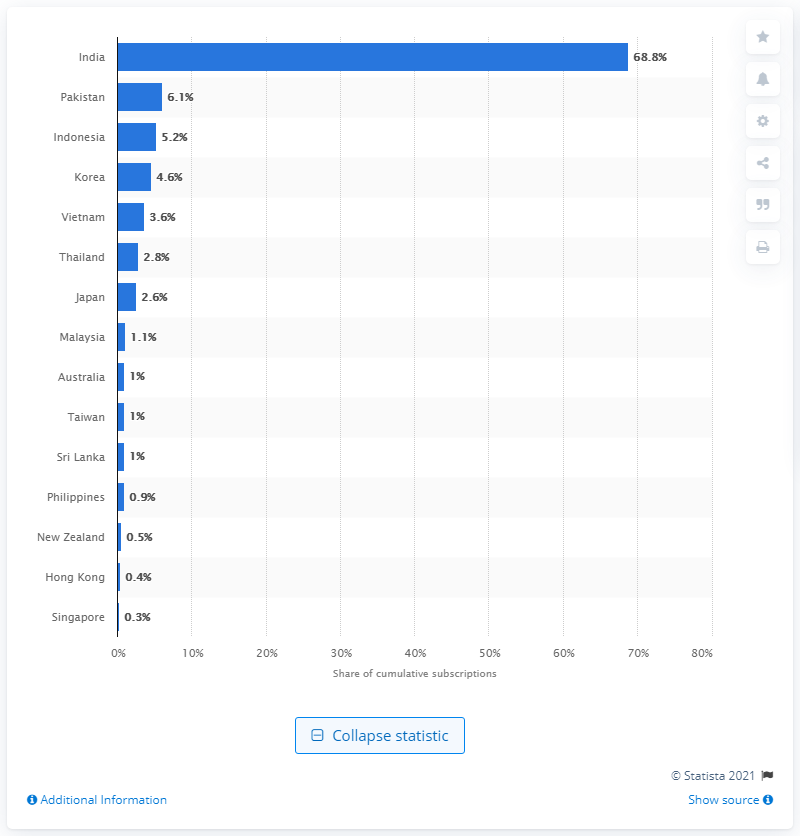Specify some key components in this picture. According to projections, India is expected to be the largest contributor to the growth of pay TV in the coming years. India accounts for approximately 68.8% of the total subscriptions. 